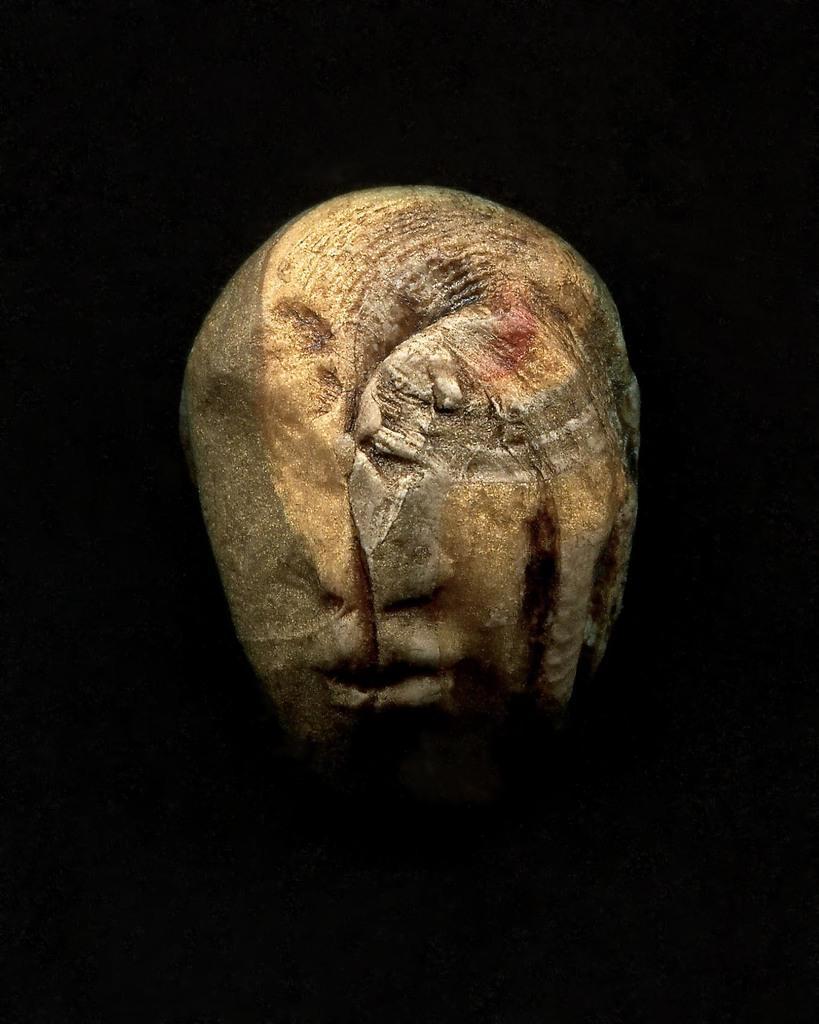Please provide a concise description of this image. This picture contains sculpture. In the background, it is black in color. 